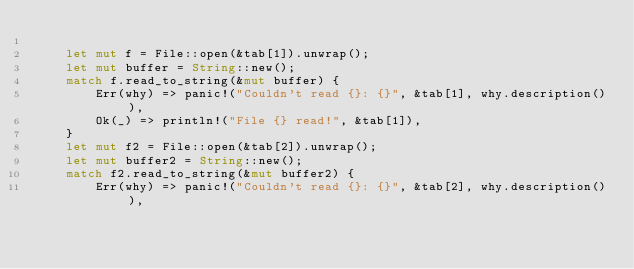Convert code to text. <code><loc_0><loc_0><loc_500><loc_500><_Rust_>
    let mut f = File::open(&tab[1]).unwrap();
    let mut buffer = String::new();
    match f.read_to_string(&mut buffer) {
        Err(why) => panic!("Couldn't read {}: {}", &tab[1], why.description()),
        Ok(_) => println!("File {} read!", &tab[1]),
    }
    let mut f2 = File::open(&tab[2]).unwrap();
    let mut buffer2 = String::new();
    match f2.read_to_string(&mut buffer2) {
        Err(why) => panic!("Couldn't read {}: {}", &tab[2], why.description()),</code> 